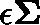<formula> <loc_0><loc_0><loc_500><loc_500>\epsilon \Sigma</formula> 